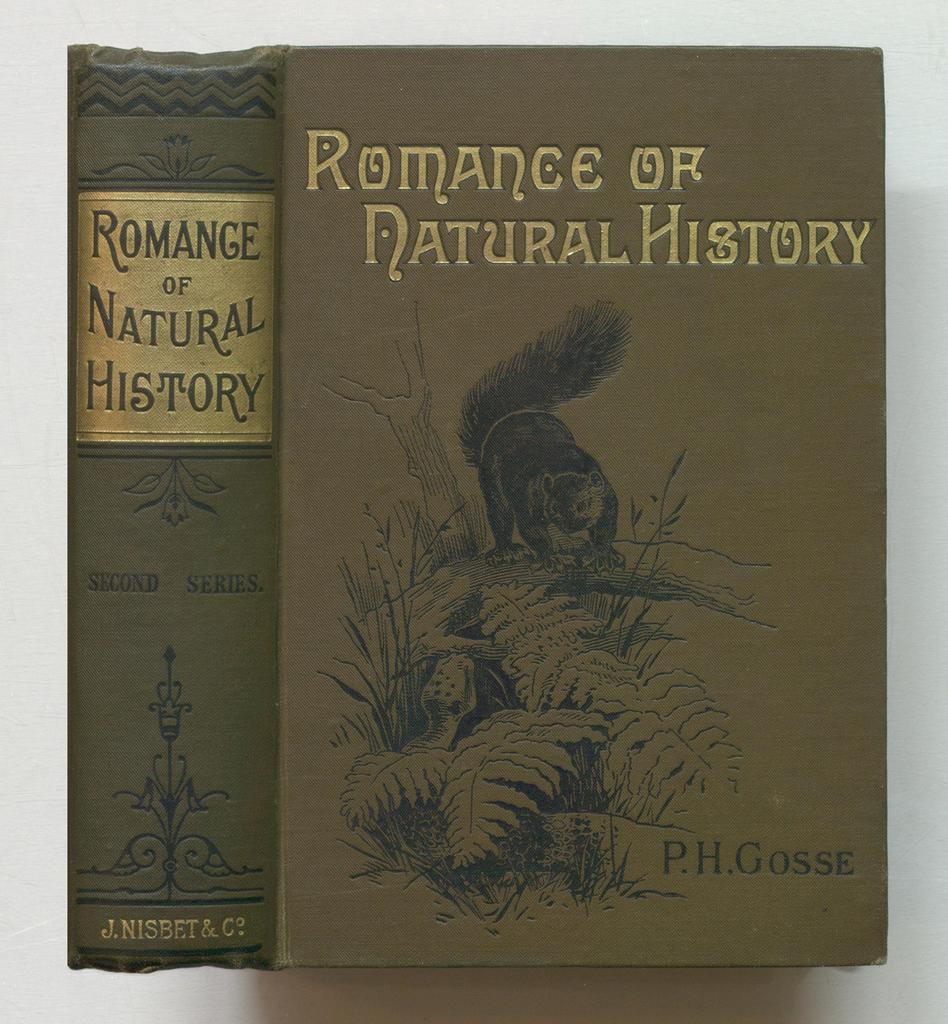Who wrote this book?
Provide a short and direct response. P.h. gosse. 